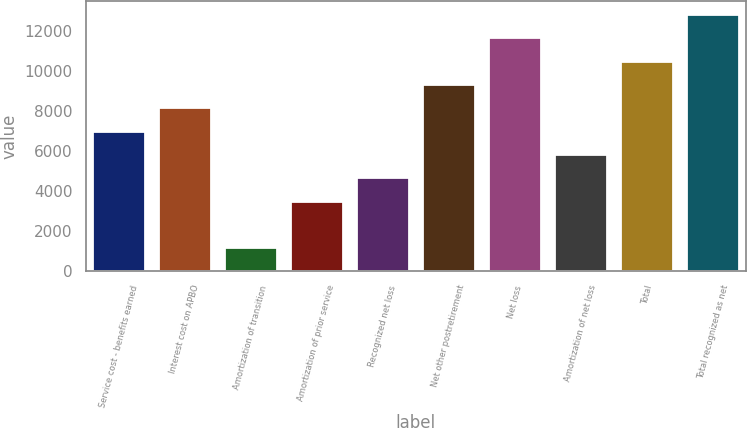Convert chart to OTSL. <chart><loc_0><loc_0><loc_500><loc_500><bar_chart><fcel>Service cost - benefits earned<fcel>Interest cost on APBO<fcel>Amortization of transition<fcel>Amortization of prior service<fcel>Recognized net loss<fcel>Net other postretirement<fcel>Net loss<fcel>Amortization of net loss<fcel>Total<fcel>Total recognized as net<nl><fcel>7018.4<fcel>8186.8<fcel>1176.4<fcel>3513.2<fcel>4681.6<fcel>9355.2<fcel>11692<fcel>5850<fcel>10523.6<fcel>12860.4<nl></chart> 